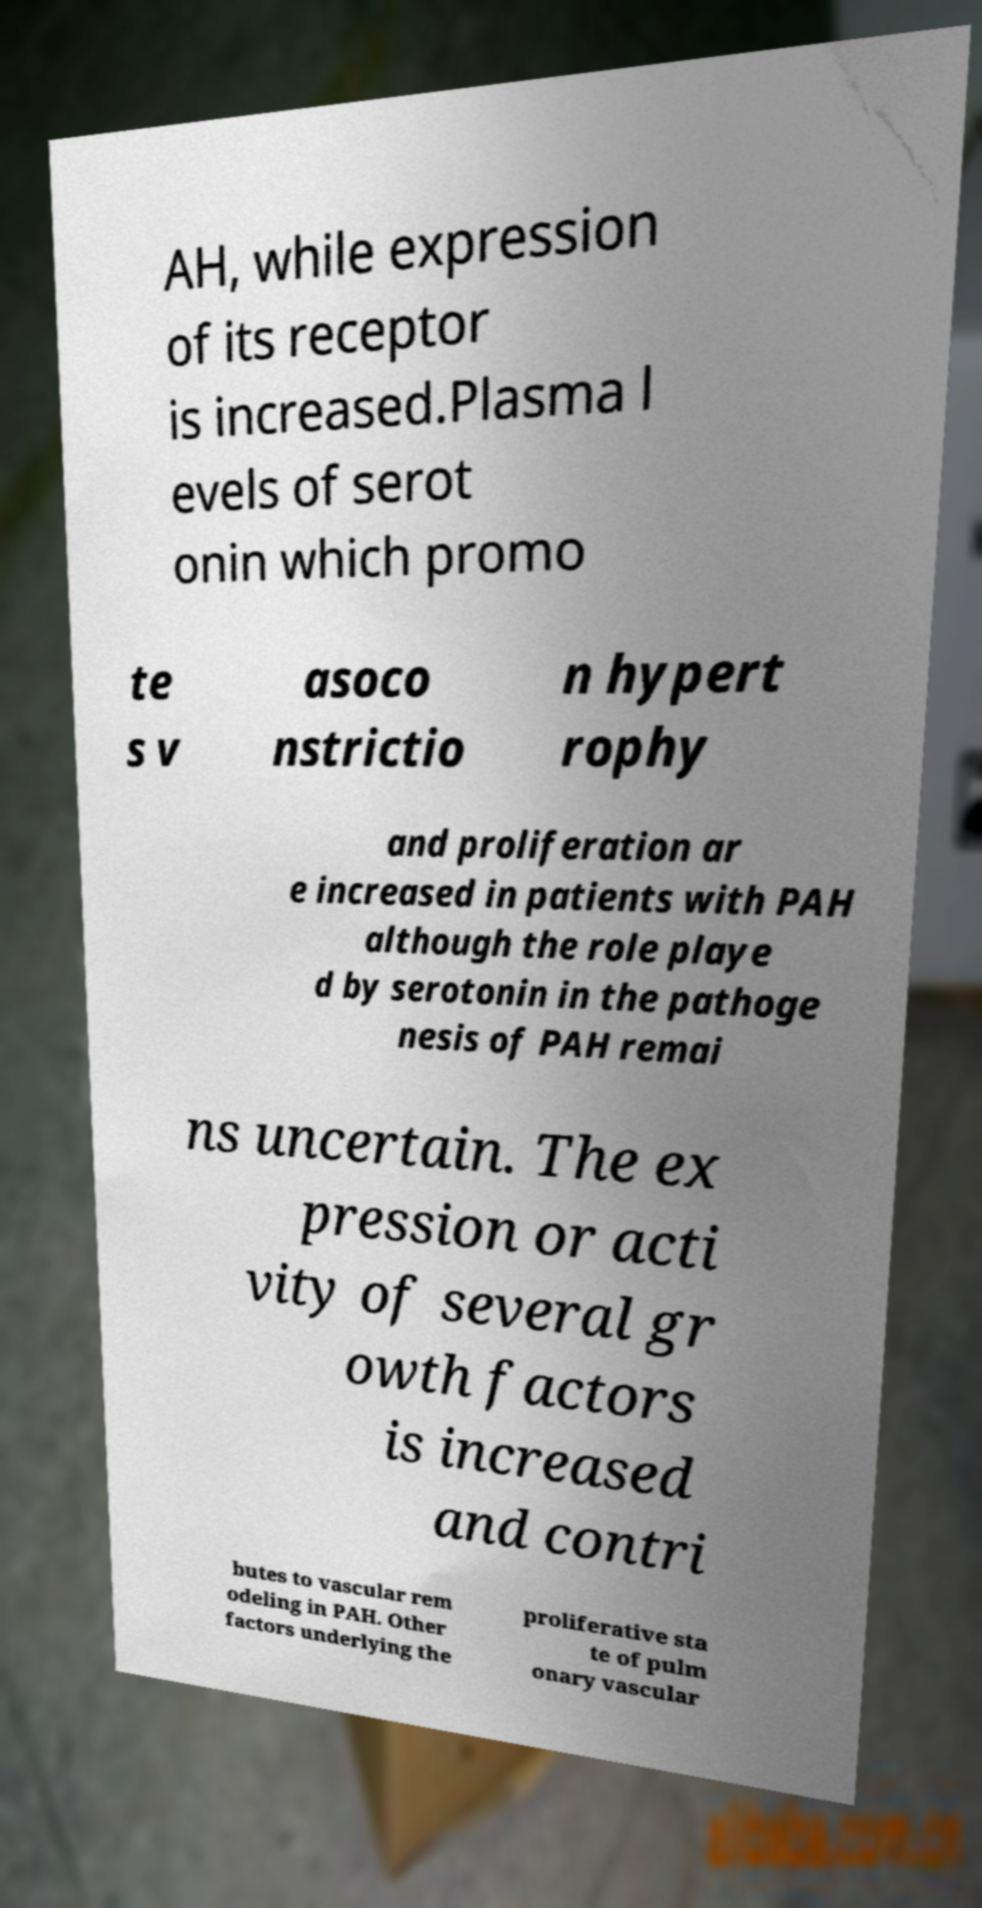For documentation purposes, I need the text within this image transcribed. Could you provide that? AH, while expression of its receptor is increased.Plasma l evels of serot onin which promo te s v asoco nstrictio n hypert rophy and proliferation ar e increased in patients with PAH although the role playe d by serotonin in the pathoge nesis of PAH remai ns uncertain. The ex pression or acti vity of several gr owth factors is increased and contri butes to vascular rem odeling in PAH. Other factors underlying the proliferative sta te of pulm onary vascular 